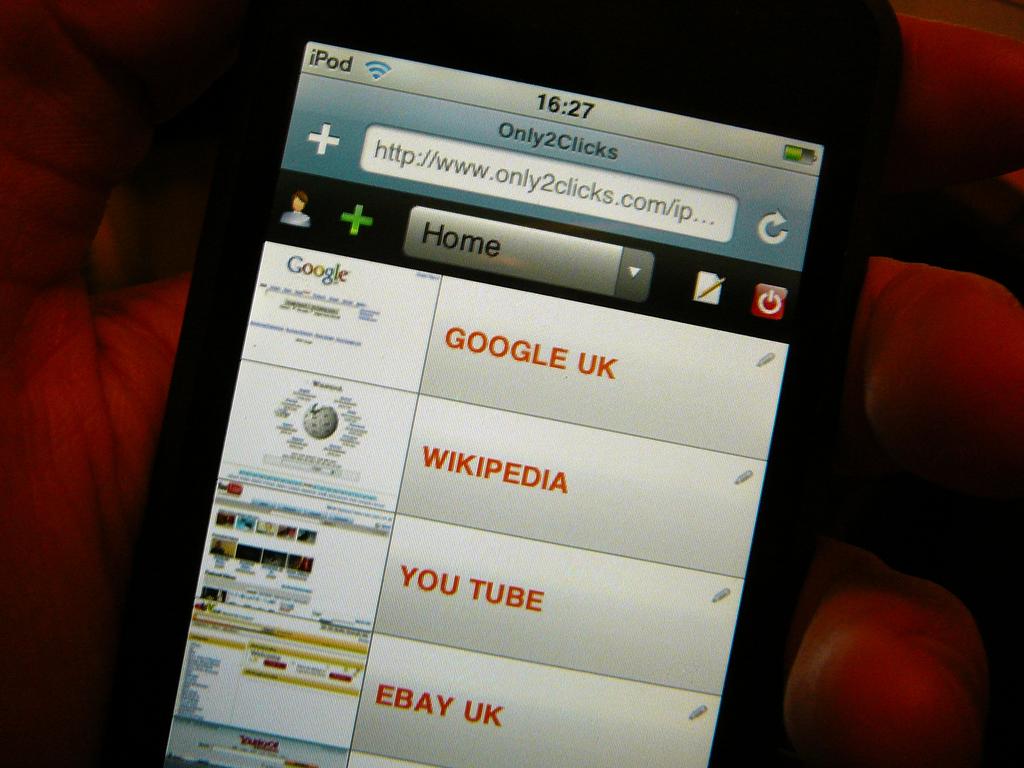What is the app called?
Offer a terse response. Only2clicks. 